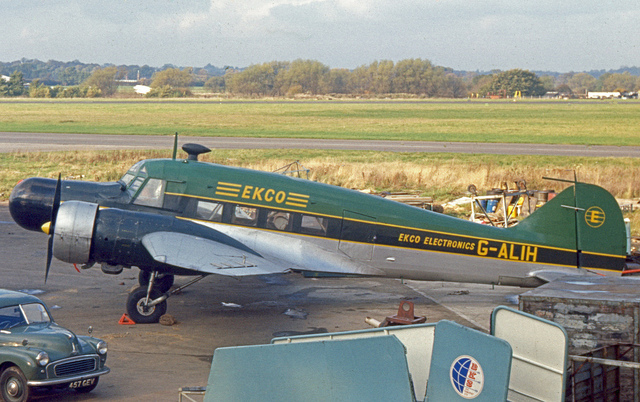Please transcribe the text in this image. EKCO ELECTRONICS G -ALIH R 457 CRV 